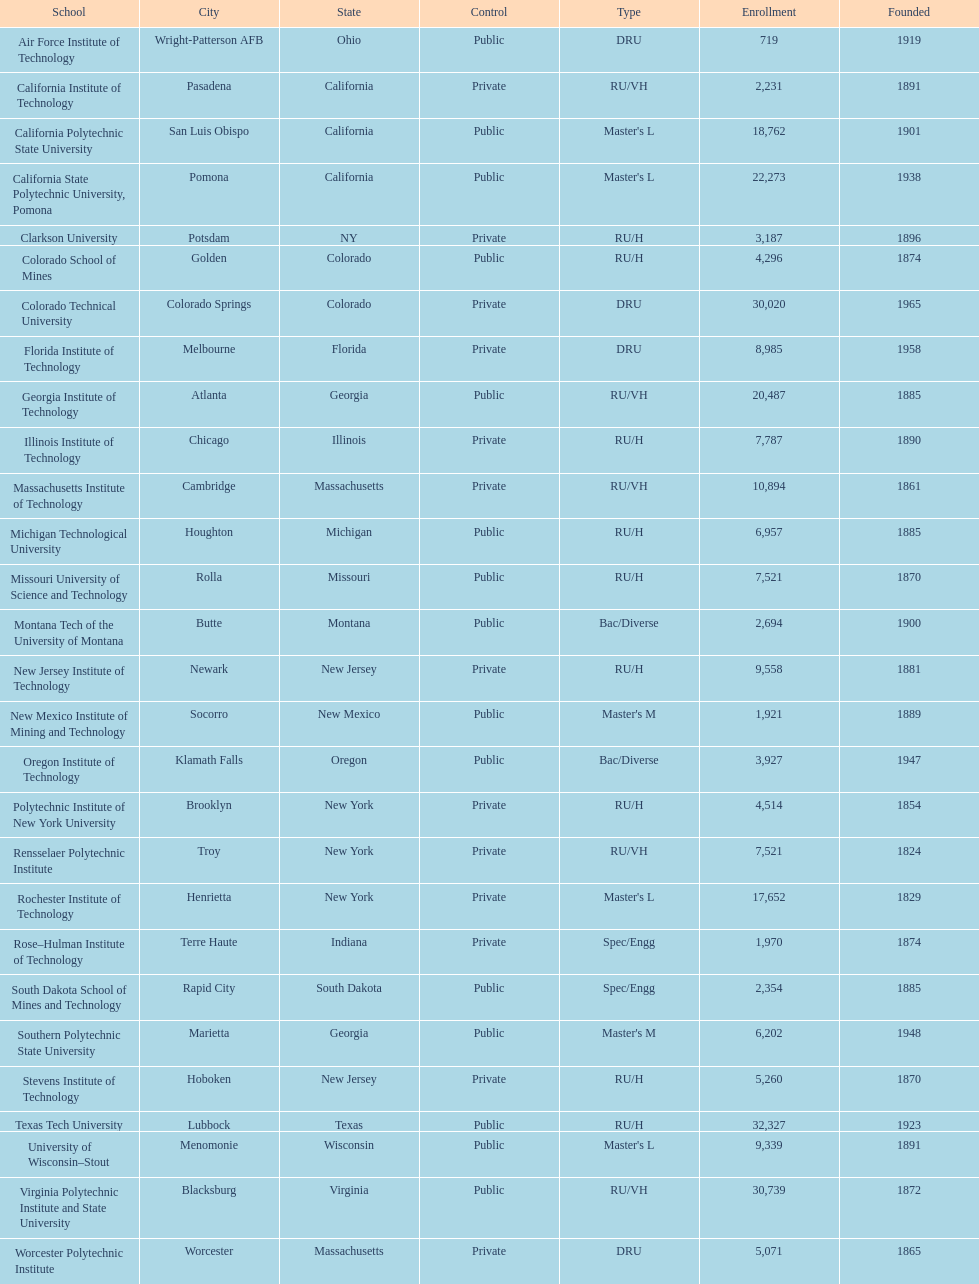What is the number of us technological schools in the state of california? 3. 